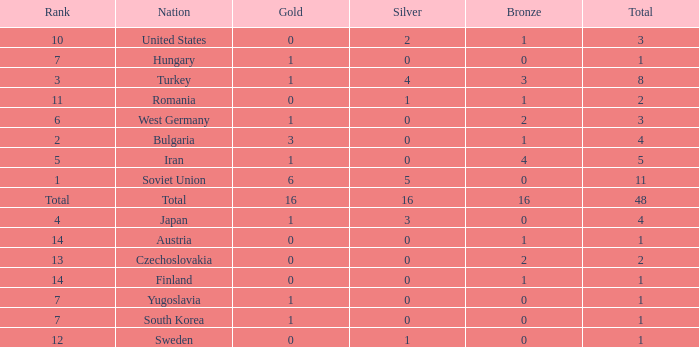How many total golds do teams have when the total medals is less than 1? None. 